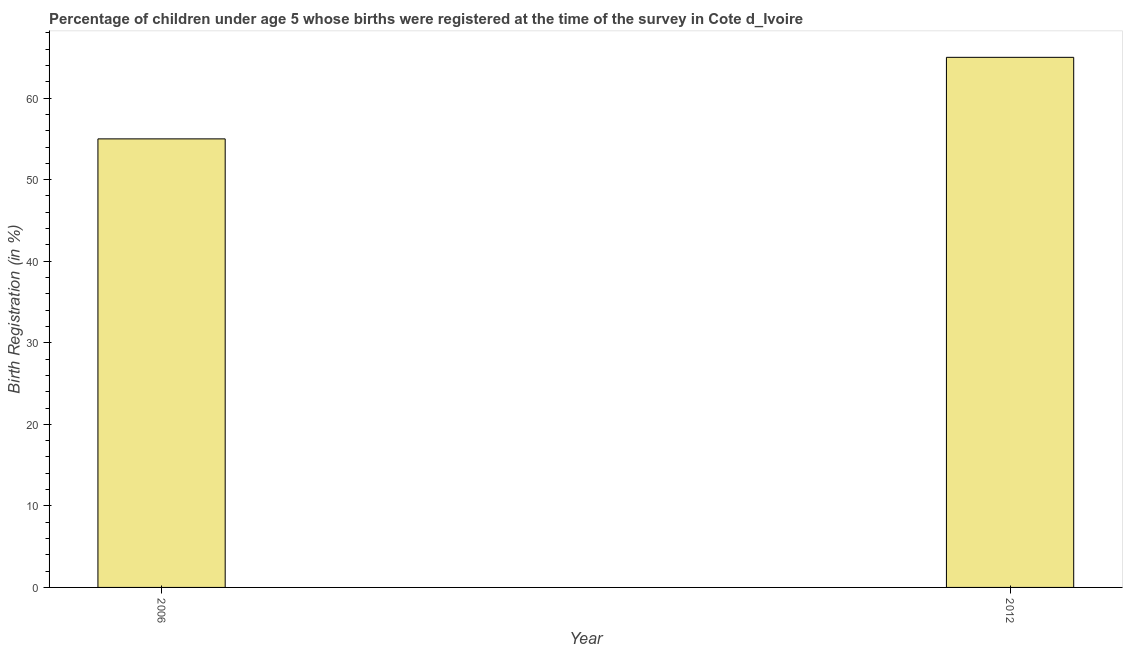Does the graph contain grids?
Ensure brevity in your answer.  No. What is the title of the graph?
Make the answer very short. Percentage of children under age 5 whose births were registered at the time of the survey in Cote d_Ivoire. What is the label or title of the X-axis?
Keep it short and to the point. Year. What is the label or title of the Y-axis?
Make the answer very short. Birth Registration (in %). Across all years, what is the maximum birth registration?
Keep it short and to the point. 65. What is the sum of the birth registration?
Your response must be concise. 120. In how many years, is the birth registration greater than 32 %?
Give a very brief answer. 2. What is the ratio of the birth registration in 2006 to that in 2012?
Provide a short and direct response. 0.85. Is the birth registration in 2006 less than that in 2012?
Your response must be concise. Yes. In how many years, is the birth registration greater than the average birth registration taken over all years?
Your answer should be very brief. 1. How many bars are there?
Provide a succinct answer. 2. How many years are there in the graph?
Provide a succinct answer. 2. What is the Birth Registration (in %) of 2006?
Provide a succinct answer. 55. What is the Birth Registration (in %) in 2012?
Provide a succinct answer. 65. What is the difference between the Birth Registration (in %) in 2006 and 2012?
Make the answer very short. -10. What is the ratio of the Birth Registration (in %) in 2006 to that in 2012?
Offer a very short reply. 0.85. 